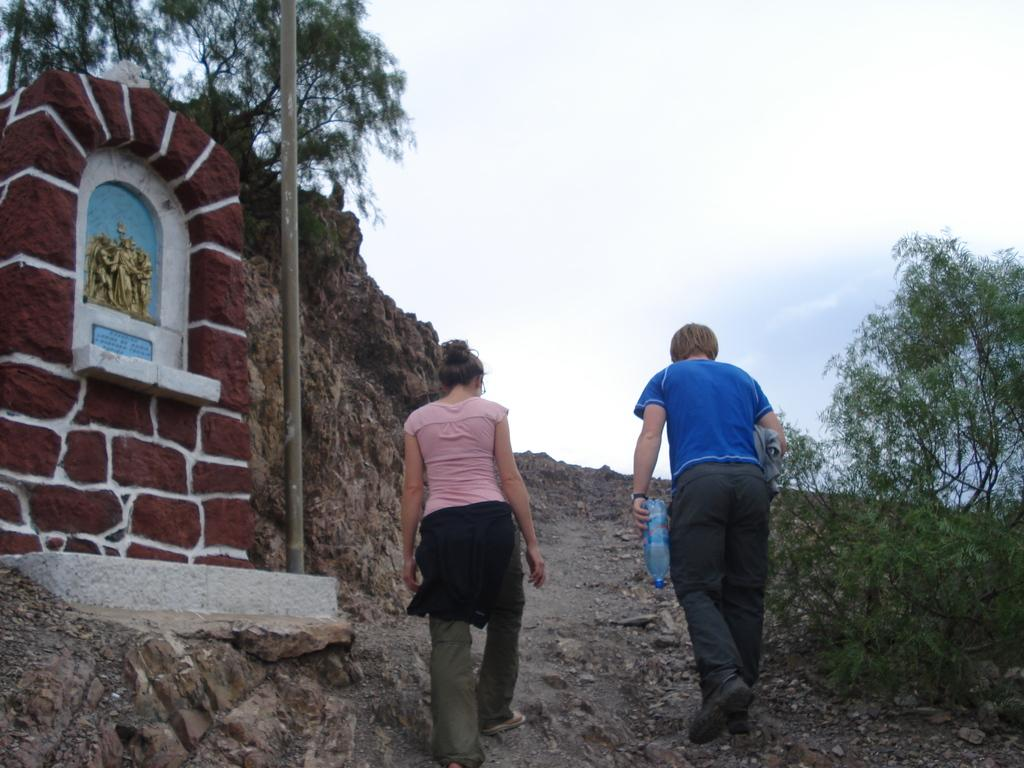What are the two persons in the image doing? The two persons in the image are walking in the middle of the image. What can be seen on the left side of the image? There is a statue on the left side of the image. What type of vegetation is present on either side of the image? There are trees on either side of the image. What is visible at the top of the image? The sky is visible at the top of the image. What type of thought can be seen floating above the statue in the image? There is no thought visible in the image; it is a statue and not a living being capable of having thoughts. 